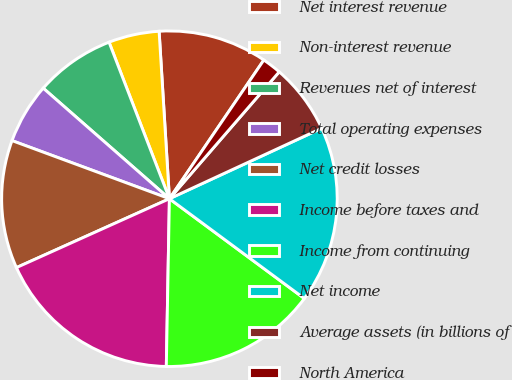Convert chart. <chart><loc_0><loc_0><loc_500><loc_500><pie_chart><fcel>Net interest revenue<fcel>Non-interest revenue<fcel>Revenues net of interest<fcel>Total operating expenses<fcel>Net credit losses<fcel>Income before taxes and<fcel>Income from continuing<fcel>Net income<fcel>Average assets (in billions of<fcel>North America<nl><fcel>10.49%<fcel>4.88%<fcel>7.69%<fcel>5.82%<fcel>12.36%<fcel>17.97%<fcel>15.16%<fcel>17.03%<fcel>6.75%<fcel>1.84%<nl></chart> 